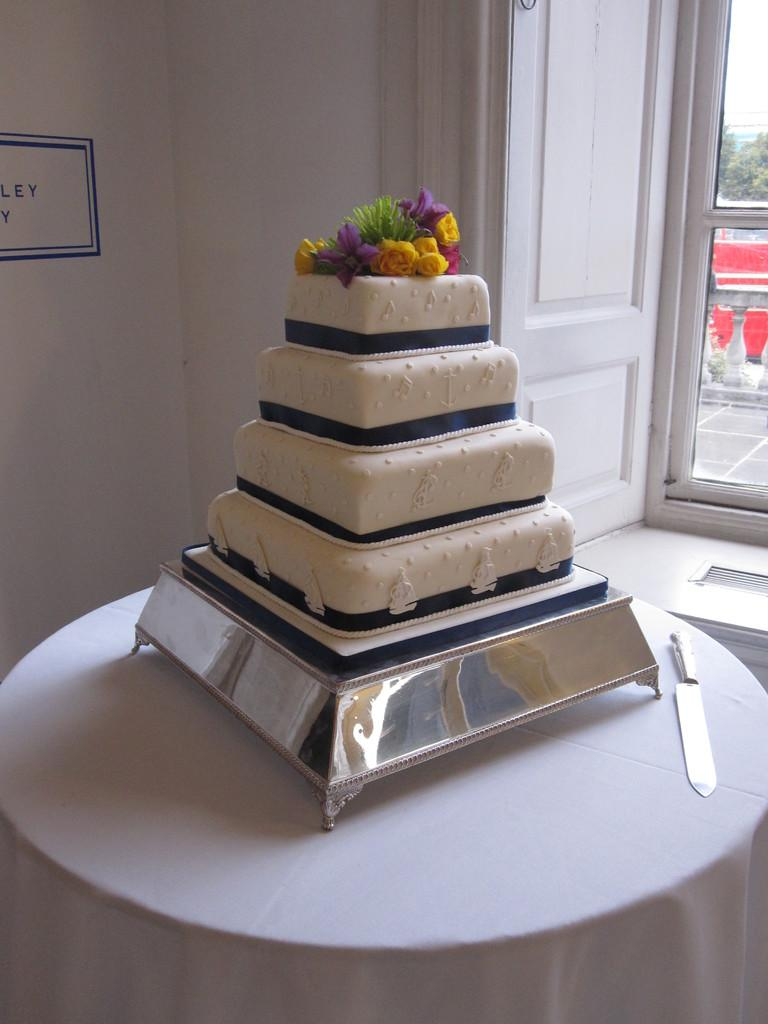What is placed on an object in the image? There is a cake placed on an object in the image. Can you describe the object on which the cake is placed? The object is on a table. What is located beside the cake? There is a knife beside the cake. What type of income can be seen being generated by the cake in the image? There is no indication of income generation in the image; it features a cake placed on an object on a table. 